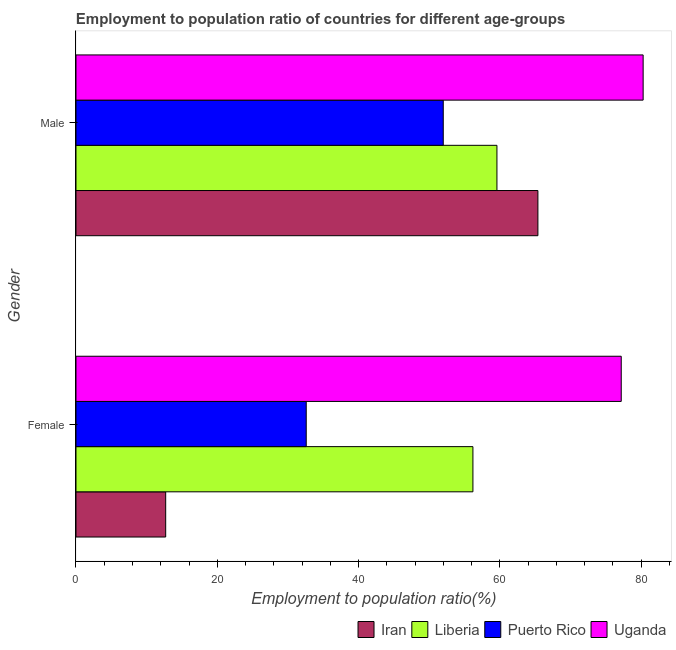How many different coloured bars are there?
Offer a terse response. 4. Are the number of bars on each tick of the Y-axis equal?
Offer a terse response. Yes. How many bars are there on the 2nd tick from the top?
Make the answer very short. 4. What is the employment to population ratio(female) in Puerto Rico?
Your answer should be compact. 32.6. Across all countries, what is the maximum employment to population ratio(male)?
Keep it short and to the point. 80.3. In which country was the employment to population ratio(female) maximum?
Provide a short and direct response. Uganda. In which country was the employment to population ratio(female) minimum?
Offer a very short reply. Iran. What is the total employment to population ratio(male) in the graph?
Ensure brevity in your answer.  257.3. What is the difference between the employment to population ratio(male) in Puerto Rico and that in Uganda?
Your response must be concise. -28.3. What is the difference between the employment to population ratio(female) in Iran and the employment to population ratio(male) in Puerto Rico?
Offer a terse response. -39.3. What is the average employment to population ratio(male) per country?
Keep it short and to the point. 64.33. What is the difference between the employment to population ratio(male) and employment to population ratio(female) in Uganda?
Give a very brief answer. 3.1. What is the ratio of the employment to population ratio(female) in Uganda to that in Iran?
Offer a very short reply. 6.08. Is the employment to population ratio(male) in Uganda less than that in Iran?
Make the answer very short. No. In how many countries, is the employment to population ratio(female) greater than the average employment to population ratio(female) taken over all countries?
Your response must be concise. 2. What does the 3rd bar from the top in Female represents?
Offer a terse response. Liberia. What does the 4th bar from the bottom in Male represents?
Provide a succinct answer. Uganda. Are all the bars in the graph horizontal?
Your answer should be compact. Yes. How many countries are there in the graph?
Keep it short and to the point. 4. Are the values on the major ticks of X-axis written in scientific E-notation?
Ensure brevity in your answer.  No. Where does the legend appear in the graph?
Provide a succinct answer. Bottom right. How many legend labels are there?
Provide a short and direct response. 4. What is the title of the graph?
Provide a short and direct response. Employment to population ratio of countries for different age-groups. What is the label or title of the X-axis?
Provide a succinct answer. Employment to population ratio(%). What is the Employment to population ratio(%) of Iran in Female?
Offer a terse response. 12.7. What is the Employment to population ratio(%) of Liberia in Female?
Offer a terse response. 56.2. What is the Employment to population ratio(%) in Puerto Rico in Female?
Offer a terse response. 32.6. What is the Employment to population ratio(%) of Uganda in Female?
Your answer should be very brief. 77.2. What is the Employment to population ratio(%) of Iran in Male?
Give a very brief answer. 65.4. What is the Employment to population ratio(%) of Liberia in Male?
Your answer should be very brief. 59.6. What is the Employment to population ratio(%) of Puerto Rico in Male?
Offer a terse response. 52. What is the Employment to population ratio(%) of Uganda in Male?
Offer a terse response. 80.3. Across all Gender, what is the maximum Employment to population ratio(%) in Iran?
Your answer should be compact. 65.4. Across all Gender, what is the maximum Employment to population ratio(%) of Liberia?
Provide a short and direct response. 59.6. Across all Gender, what is the maximum Employment to population ratio(%) of Puerto Rico?
Give a very brief answer. 52. Across all Gender, what is the maximum Employment to population ratio(%) in Uganda?
Offer a very short reply. 80.3. Across all Gender, what is the minimum Employment to population ratio(%) of Iran?
Offer a very short reply. 12.7. Across all Gender, what is the minimum Employment to population ratio(%) in Liberia?
Provide a succinct answer. 56.2. Across all Gender, what is the minimum Employment to population ratio(%) of Puerto Rico?
Offer a terse response. 32.6. Across all Gender, what is the minimum Employment to population ratio(%) in Uganda?
Ensure brevity in your answer.  77.2. What is the total Employment to population ratio(%) of Iran in the graph?
Offer a terse response. 78.1. What is the total Employment to population ratio(%) of Liberia in the graph?
Your answer should be very brief. 115.8. What is the total Employment to population ratio(%) of Puerto Rico in the graph?
Give a very brief answer. 84.6. What is the total Employment to population ratio(%) in Uganda in the graph?
Your answer should be compact. 157.5. What is the difference between the Employment to population ratio(%) in Iran in Female and that in Male?
Your response must be concise. -52.7. What is the difference between the Employment to population ratio(%) of Liberia in Female and that in Male?
Keep it short and to the point. -3.4. What is the difference between the Employment to population ratio(%) in Puerto Rico in Female and that in Male?
Give a very brief answer. -19.4. What is the difference between the Employment to population ratio(%) of Uganda in Female and that in Male?
Make the answer very short. -3.1. What is the difference between the Employment to population ratio(%) of Iran in Female and the Employment to population ratio(%) of Liberia in Male?
Give a very brief answer. -46.9. What is the difference between the Employment to population ratio(%) of Iran in Female and the Employment to population ratio(%) of Puerto Rico in Male?
Give a very brief answer. -39.3. What is the difference between the Employment to population ratio(%) in Iran in Female and the Employment to population ratio(%) in Uganda in Male?
Your answer should be compact. -67.6. What is the difference between the Employment to population ratio(%) in Liberia in Female and the Employment to population ratio(%) in Puerto Rico in Male?
Provide a succinct answer. 4.2. What is the difference between the Employment to population ratio(%) in Liberia in Female and the Employment to population ratio(%) in Uganda in Male?
Your response must be concise. -24.1. What is the difference between the Employment to population ratio(%) of Puerto Rico in Female and the Employment to population ratio(%) of Uganda in Male?
Offer a terse response. -47.7. What is the average Employment to population ratio(%) in Iran per Gender?
Provide a succinct answer. 39.05. What is the average Employment to population ratio(%) of Liberia per Gender?
Keep it short and to the point. 57.9. What is the average Employment to population ratio(%) in Puerto Rico per Gender?
Provide a succinct answer. 42.3. What is the average Employment to population ratio(%) in Uganda per Gender?
Make the answer very short. 78.75. What is the difference between the Employment to population ratio(%) of Iran and Employment to population ratio(%) of Liberia in Female?
Your answer should be very brief. -43.5. What is the difference between the Employment to population ratio(%) of Iran and Employment to population ratio(%) of Puerto Rico in Female?
Provide a short and direct response. -19.9. What is the difference between the Employment to population ratio(%) of Iran and Employment to population ratio(%) of Uganda in Female?
Your answer should be very brief. -64.5. What is the difference between the Employment to population ratio(%) of Liberia and Employment to population ratio(%) of Puerto Rico in Female?
Give a very brief answer. 23.6. What is the difference between the Employment to population ratio(%) in Liberia and Employment to population ratio(%) in Uganda in Female?
Make the answer very short. -21. What is the difference between the Employment to population ratio(%) in Puerto Rico and Employment to population ratio(%) in Uganda in Female?
Provide a short and direct response. -44.6. What is the difference between the Employment to population ratio(%) in Iran and Employment to population ratio(%) in Liberia in Male?
Provide a succinct answer. 5.8. What is the difference between the Employment to population ratio(%) of Iran and Employment to population ratio(%) of Uganda in Male?
Provide a succinct answer. -14.9. What is the difference between the Employment to population ratio(%) in Liberia and Employment to population ratio(%) in Puerto Rico in Male?
Give a very brief answer. 7.6. What is the difference between the Employment to population ratio(%) of Liberia and Employment to population ratio(%) of Uganda in Male?
Provide a short and direct response. -20.7. What is the difference between the Employment to population ratio(%) in Puerto Rico and Employment to population ratio(%) in Uganda in Male?
Offer a very short reply. -28.3. What is the ratio of the Employment to population ratio(%) of Iran in Female to that in Male?
Your answer should be compact. 0.19. What is the ratio of the Employment to population ratio(%) of Liberia in Female to that in Male?
Your answer should be compact. 0.94. What is the ratio of the Employment to population ratio(%) of Puerto Rico in Female to that in Male?
Keep it short and to the point. 0.63. What is the ratio of the Employment to population ratio(%) of Uganda in Female to that in Male?
Offer a terse response. 0.96. What is the difference between the highest and the second highest Employment to population ratio(%) in Iran?
Your answer should be very brief. 52.7. What is the difference between the highest and the second highest Employment to population ratio(%) of Puerto Rico?
Provide a short and direct response. 19.4. What is the difference between the highest and the lowest Employment to population ratio(%) of Iran?
Keep it short and to the point. 52.7. What is the difference between the highest and the lowest Employment to population ratio(%) in Liberia?
Give a very brief answer. 3.4. What is the difference between the highest and the lowest Employment to population ratio(%) of Puerto Rico?
Your answer should be compact. 19.4. What is the difference between the highest and the lowest Employment to population ratio(%) in Uganda?
Offer a terse response. 3.1. 